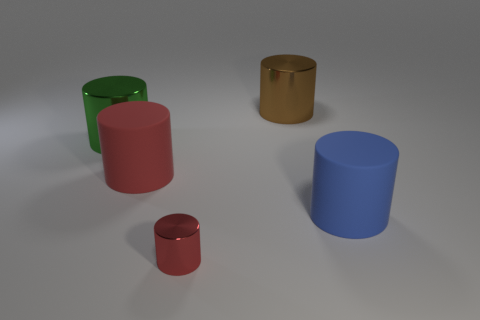Subtract all green metal cylinders. How many cylinders are left? 4 Add 3 big brown metal things. How many objects exist? 8 Subtract all blue cylinders. How many cylinders are left? 4 Subtract 3 cylinders. How many cylinders are left? 2 Subtract all brown blocks. How many green cylinders are left? 1 Subtract all large red cylinders. Subtract all yellow cylinders. How many objects are left? 4 Add 5 red matte cylinders. How many red matte cylinders are left? 6 Add 1 purple shiny spheres. How many purple shiny spheres exist? 1 Subtract 0 cyan cubes. How many objects are left? 5 Subtract all red cylinders. Subtract all cyan cubes. How many cylinders are left? 3 